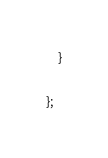<code> <loc_0><loc_0><loc_500><loc_500><_JavaScript_>    }

};
</code> 